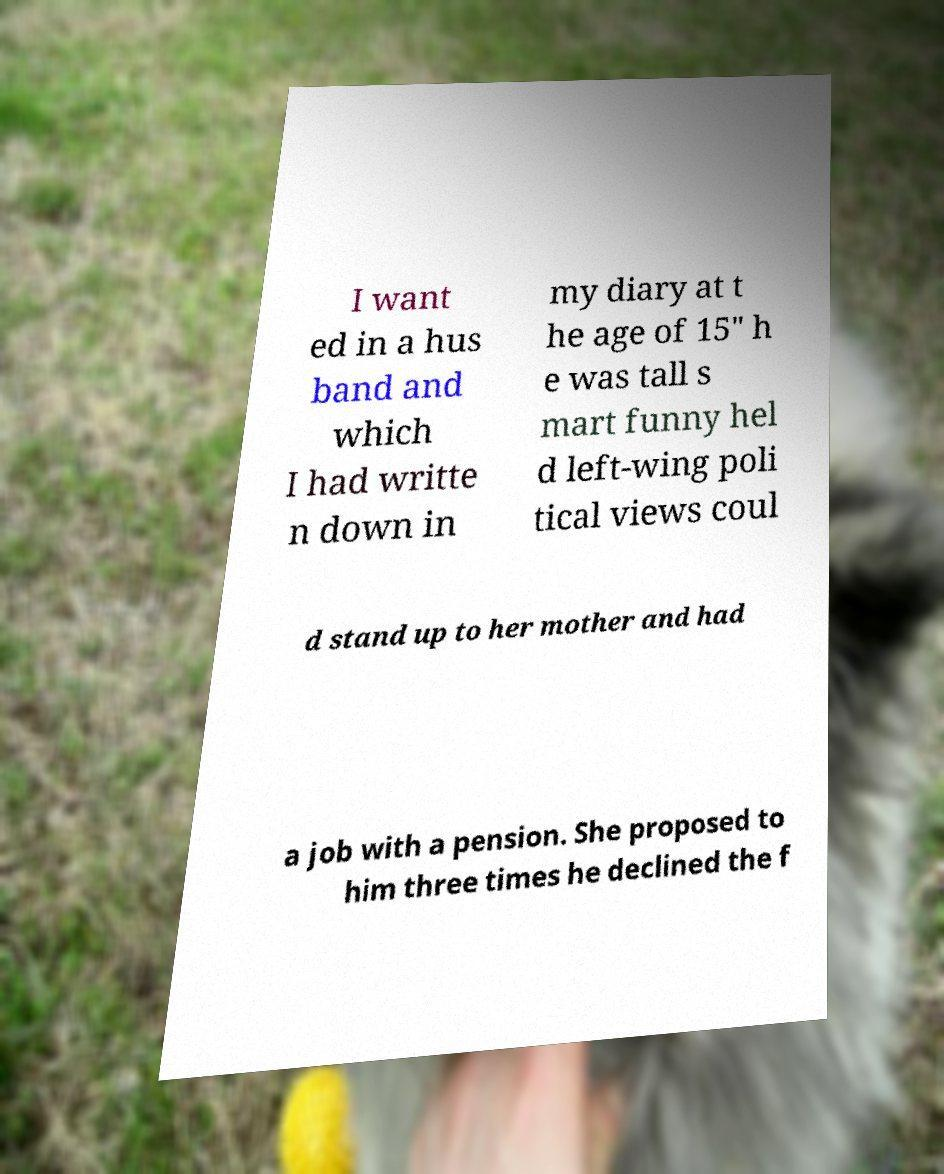Please identify and transcribe the text found in this image. I want ed in a hus band and which I had writte n down in my diary at t he age of 15" h e was tall s mart funny hel d left-wing poli tical views coul d stand up to her mother and had a job with a pension. She proposed to him three times he declined the f 